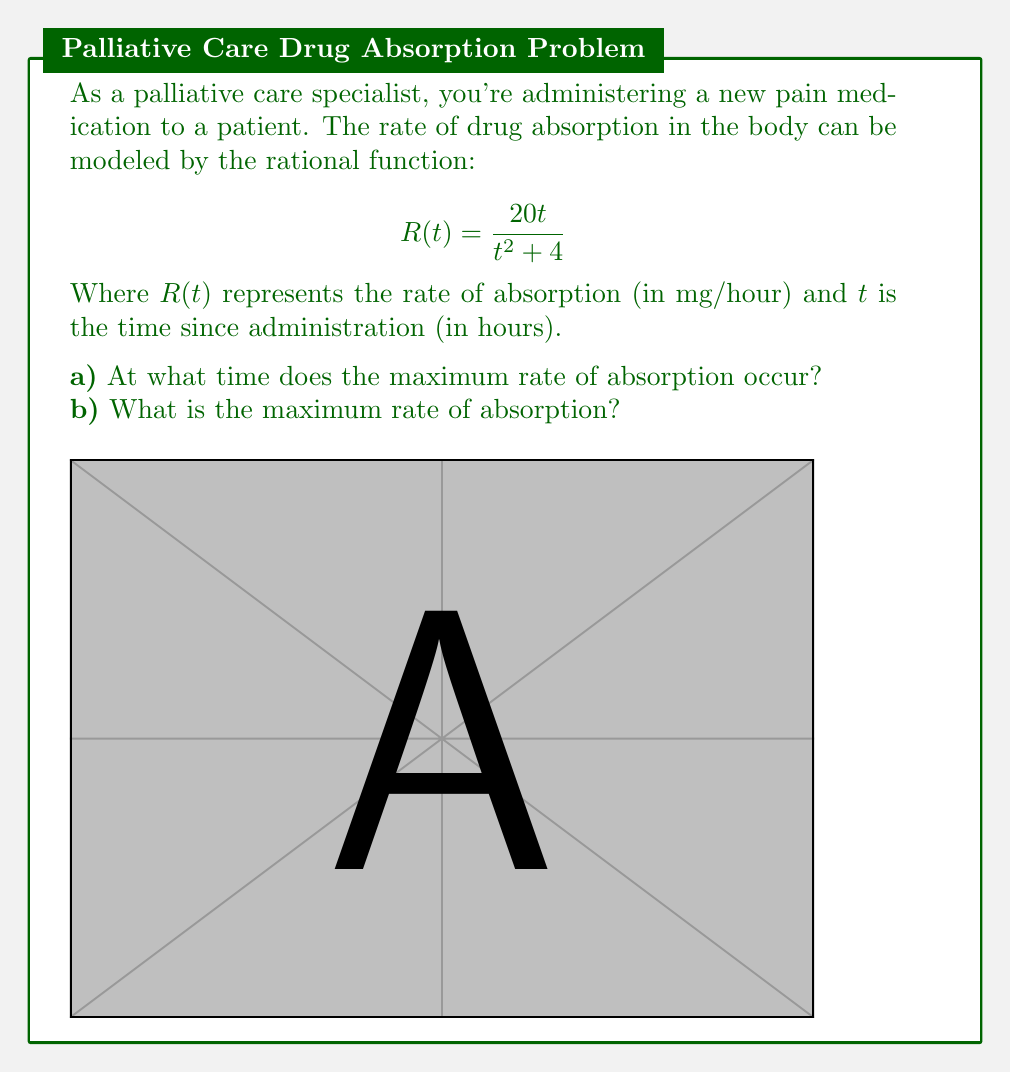Provide a solution to this math problem. Let's approach this step-by-step:

1) To find the maximum rate of absorption, we need to find the critical points of $R(t)$. We do this by taking the derivative and setting it equal to zero.

2) Using the quotient rule, the derivative of $R(t)$ is:

   $$R'(t) = \frac{(t^2+4)(20) - 20t(2t)}{(t^2+4)^2} = \frac{20(t^2+4) - 40t^2}{(t^2+4)^2} = \frac{20(4-t^2)}{(t^2+4)^2}$$

3) Set $R'(t) = 0$ and solve:

   $$\frac{20(4-t^2)}{(t^2+4)^2} = 0$$

   The numerator must be zero (the denominator is always positive for real $t$):

   $$20(4-t^2) = 0$$
   $$4-t^2 = 0$$
   $$t^2 = 4$$
   $$t = \pm 2$$

4) Since time can't be negative in this context, the critical point is at $t = 2$ hours.

5) To confirm this is a maximum (not a minimum), we can observe that $R'(t)$ is positive for $0 < t < 2$ and negative for $t > 2$.

6) To find the maximum rate, we evaluate $R(2)$:

   $$R(2) = \frac{20(2)}{2^2 + 4} = \frac{40}{8} = 5$$ mg/hour

Therefore, the maximum rate of absorption occurs at 2 hours after administration, and the maximum rate is 5 mg/hour.
Answer: a) 2 hours
b) 5 mg/hour 